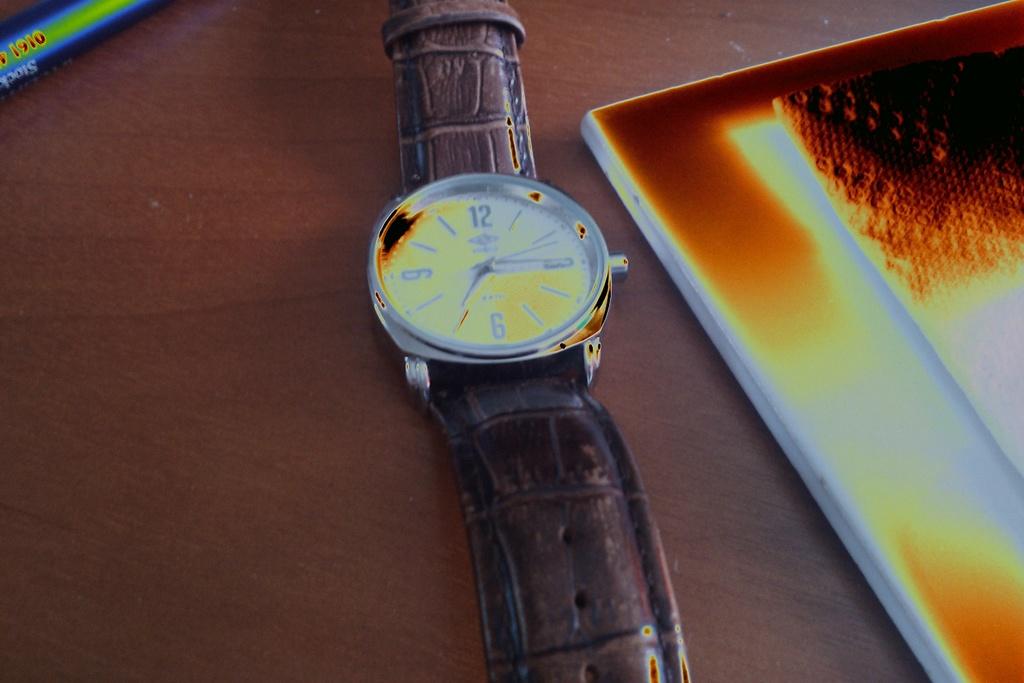What time does this watch read?
Ensure brevity in your answer.  7:15. 